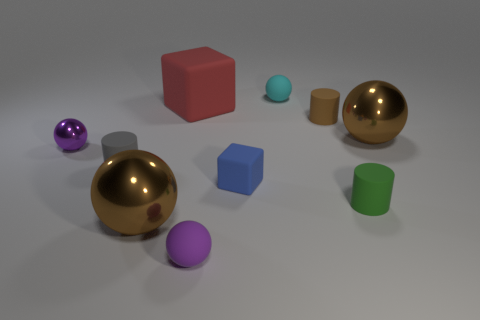Subtract 1 spheres. How many spheres are left? 4 Subtract all cyan spheres. How many spheres are left? 4 Subtract all tiny purple shiny spheres. How many spheres are left? 4 Subtract all green cylinders. Subtract all green balls. How many cylinders are left? 2 Subtract all blocks. How many objects are left? 8 Subtract all green blocks. Subtract all brown metal things. How many objects are left? 8 Add 7 tiny purple rubber balls. How many tiny purple rubber balls are left? 8 Add 9 big matte blocks. How many big matte blocks exist? 10 Subtract 0 purple cylinders. How many objects are left? 10 